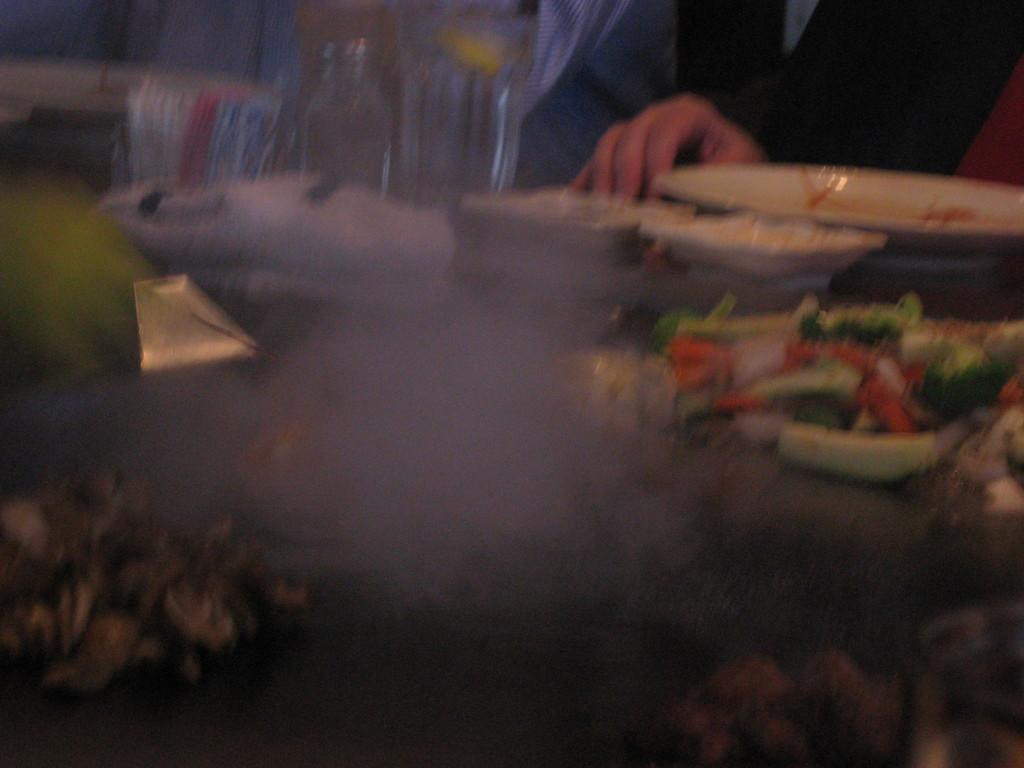What is the condition of a part of the image? Some portion of the image is blurred. What can be seen on the right side of the image? There are food items in plates and bowls on the right side of the image. Can you identify any people in the image? Yes, there is at least one person sitting in the image. What type of curve can be seen in the image? There is no curve present in the image. What kind of apparatus is being used by the person in the image? The image does not show any apparatus being used by the person. 